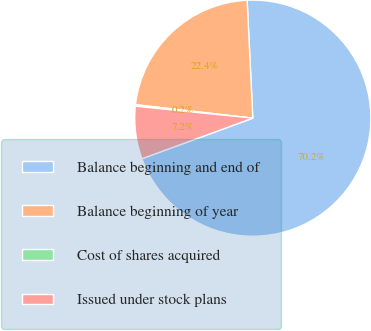<chart> <loc_0><loc_0><loc_500><loc_500><pie_chart><fcel>Balance beginning and end of<fcel>Balance beginning of year<fcel>Cost of shares acquired<fcel>Issued under stock plans<nl><fcel>70.18%<fcel>22.42%<fcel>0.2%<fcel>7.2%<nl></chart> 